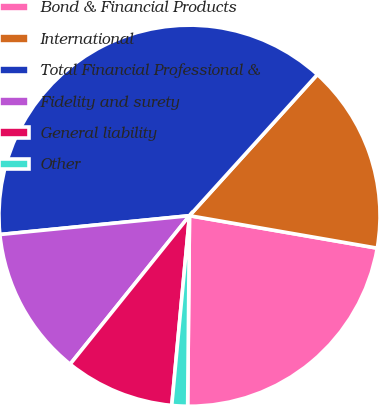<chart> <loc_0><loc_0><loc_500><loc_500><pie_chart><fcel>Bond & Financial Products<fcel>International<fcel>Total Financial Professional &<fcel>Fidelity and surety<fcel>General liability<fcel>Other<nl><fcel>22.43%<fcel>16.01%<fcel>38.29%<fcel>12.65%<fcel>9.29%<fcel>1.33%<nl></chart> 